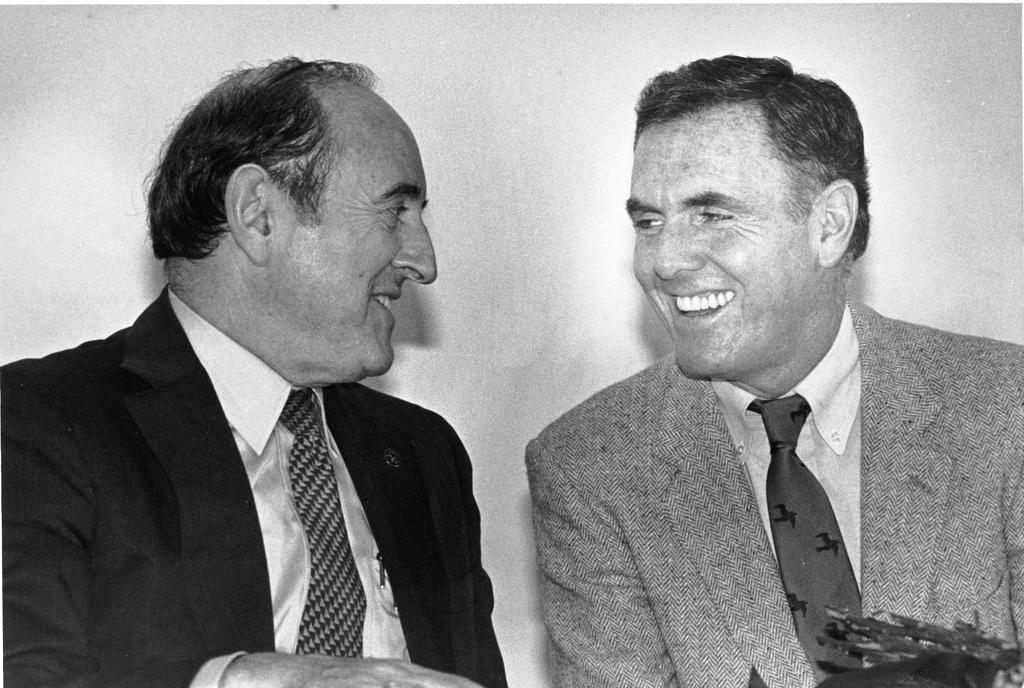Please provide a concise description of this image. This is a black and white picture of two men in suits talking with each other, behind them there is wall. 